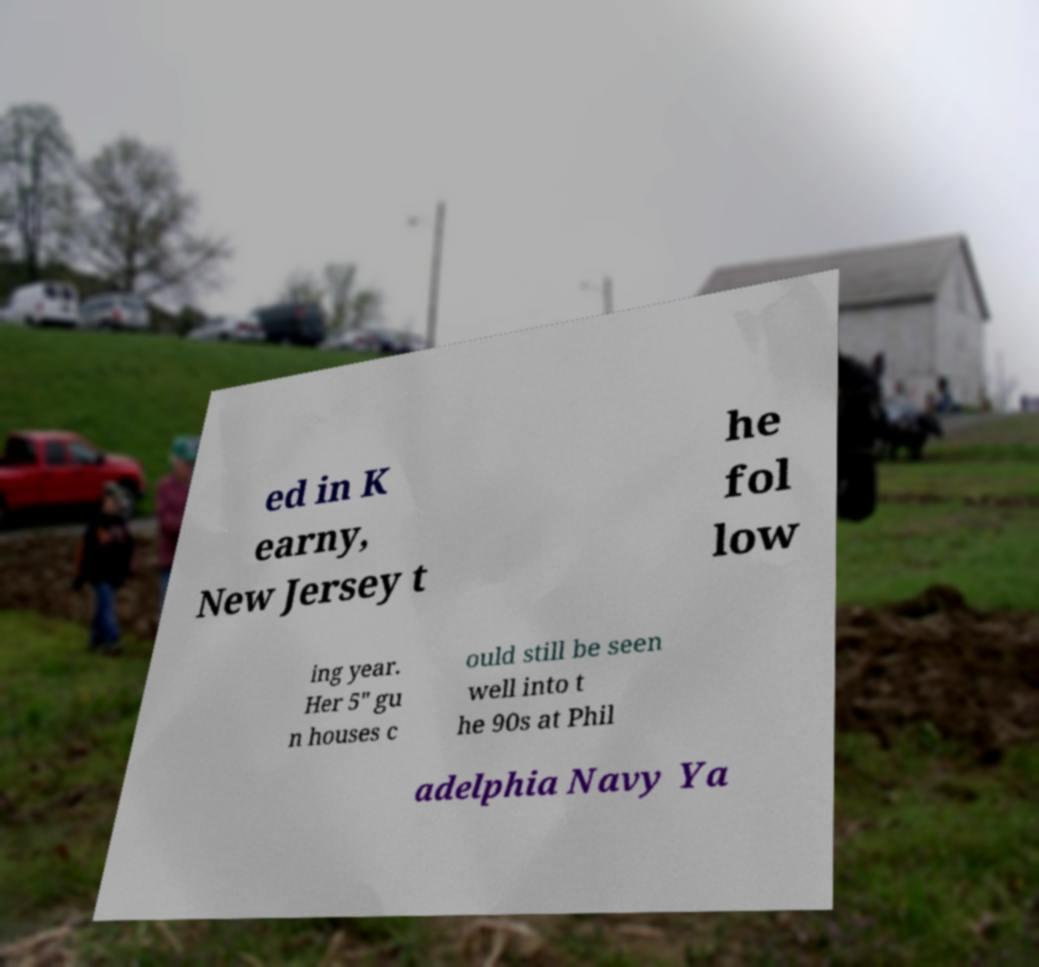For documentation purposes, I need the text within this image transcribed. Could you provide that? ed in K earny, New Jersey t he fol low ing year. Her 5" gu n houses c ould still be seen well into t he 90s at Phil adelphia Navy Ya 